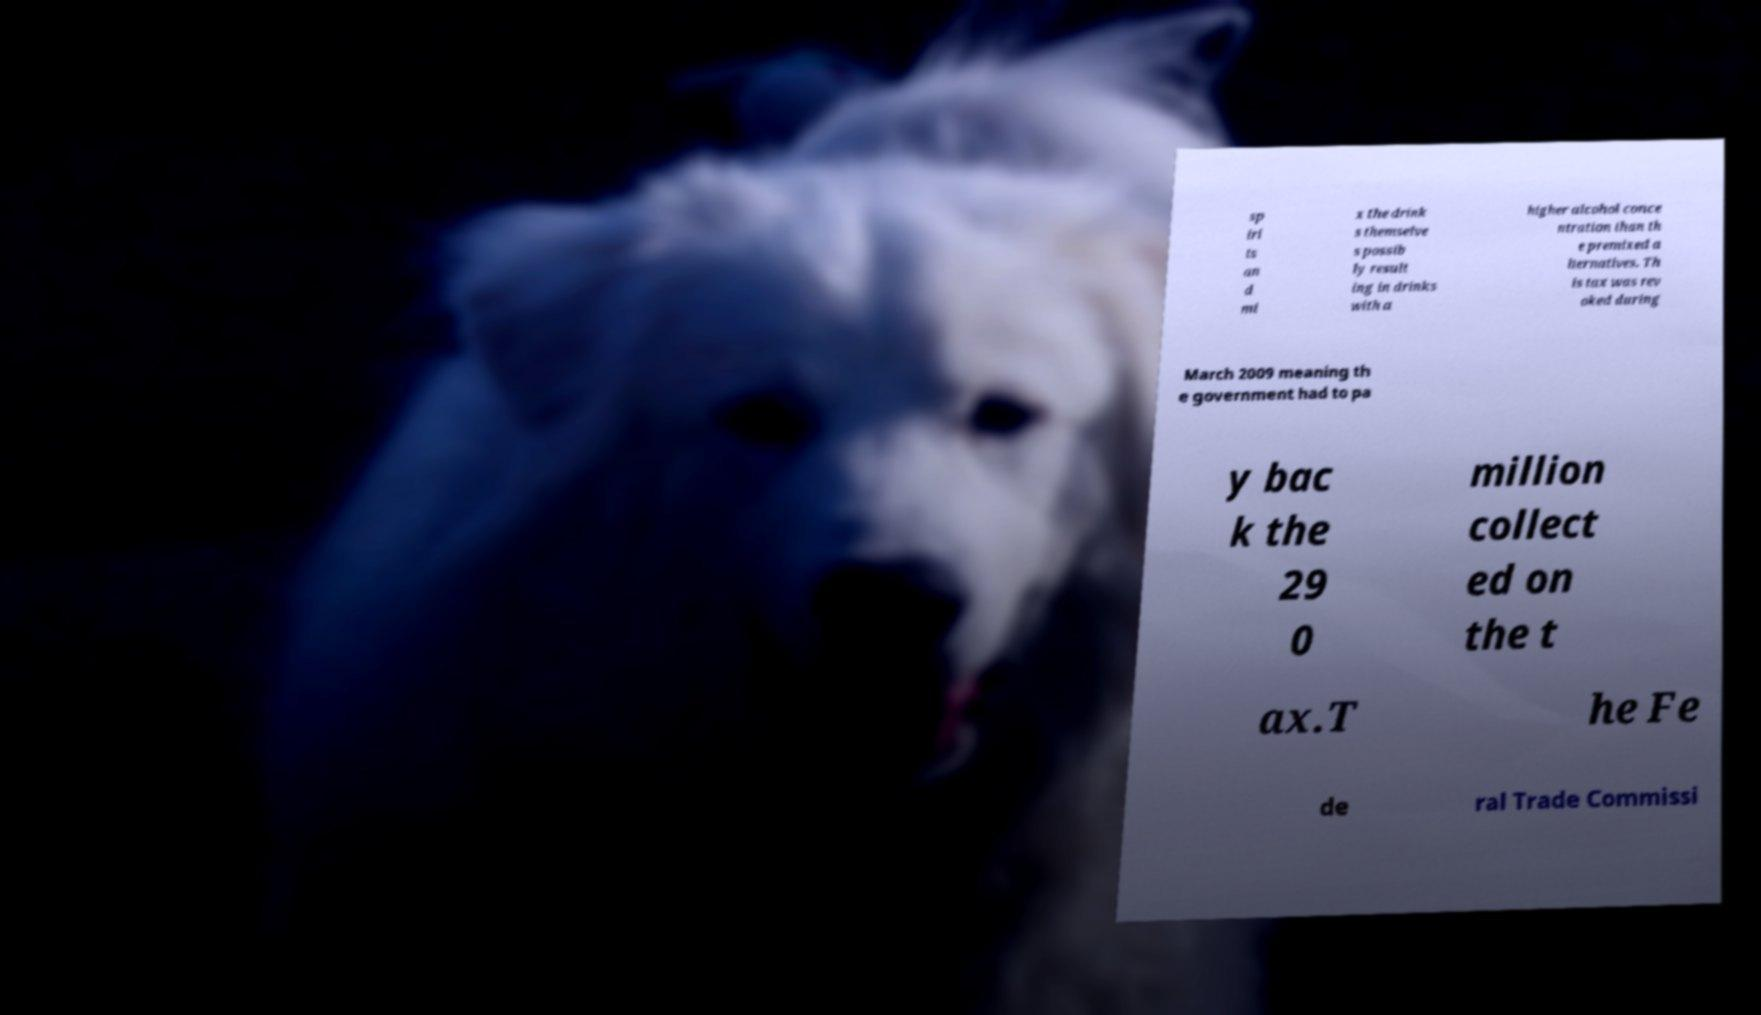I need the written content from this picture converted into text. Can you do that? sp iri ts an d mi x the drink s themselve s possib ly result ing in drinks with a higher alcohol conce ntration than th e premixed a lternatives. Th is tax was rev oked during March 2009 meaning th e government had to pa y bac k the 29 0 million collect ed on the t ax.T he Fe de ral Trade Commissi 